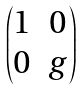<formula> <loc_0><loc_0><loc_500><loc_500>\begin{pmatrix} 1 & 0 \\ 0 & g \end{pmatrix}</formula> 